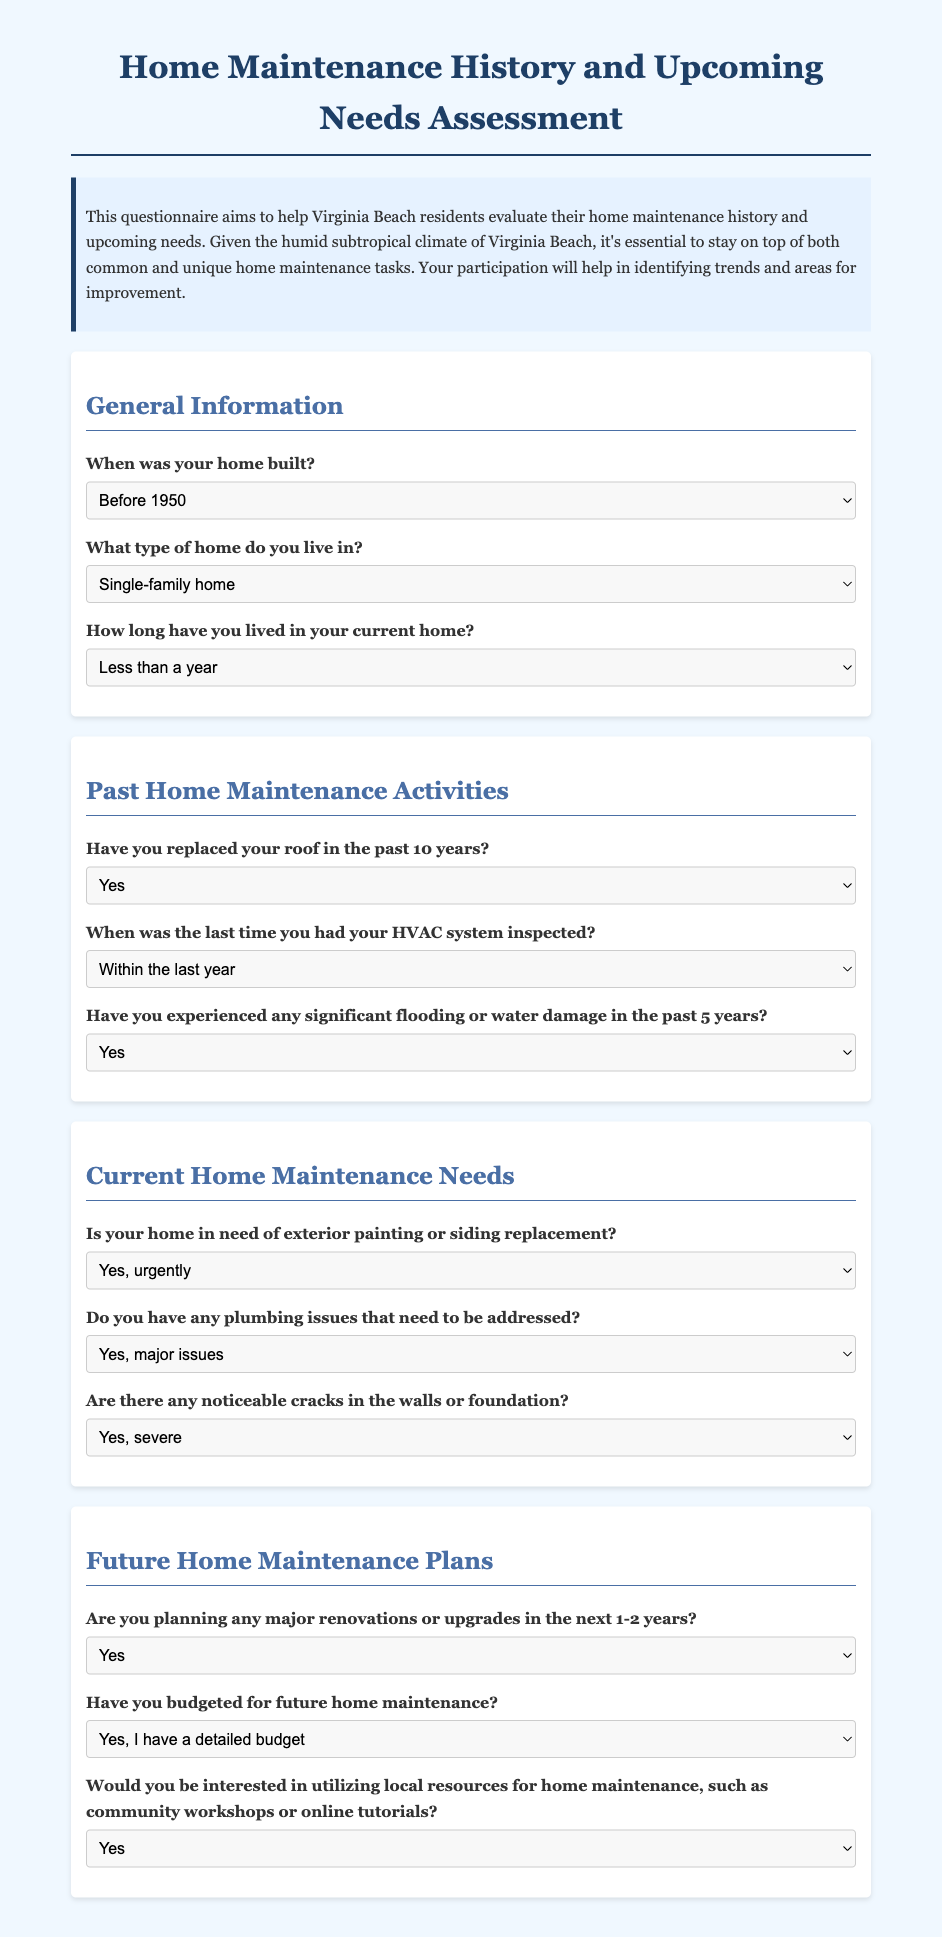What is the title of the document? The title of the document is specified within the <title> tag of the HTML, which is "Home Maintenance Questionnaire".
Answer: Home Maintenance Questionnaire How many sections are there in the questionnaire? The document contains four distinct sections outlined in the HTML structure for the questionnaire: General Information, Past Home Maintenance Activities, Current Home Maintenance Needs, and Future Home Maintenance Plans.
Answer: Four What is one of the options for the question about the type of home? The options for the type of home include several categories, one of which is specified as "Condo".
Answer: Condo When was the last time you had your HVAC system inspected? This question has several options available in the dropdown, including one stating "1-3 years ago".
Answer: 1-3 years ago Is there a question regarding plumbing issues in the document? The document includes a question about plumbing issues, specifically focusing on whether there are any major or minor concerns.
Answer: Yes How long have you lived in your current home? One of the options provided for this question is "4-7 years".
Answer: 4-7 years What background color is used for the introduction section? The introduction section of the document has a background color specified as light blue, noted as "#e6f2ff" in the CSS style.
Answer: Light blue Are there options to indicate urgency for exterior painting needs? Yes, there are options for exterior painting needs that include "Yes, urgently" and "Yes, but can wait".
Answer: Yes Does the questionnaire ask about planned renovations in the next 1-2 years? The questionnaire includes a query regarding whether respondents are planning any major renovations or upgrades in that timeframe.
Answer: Yes 